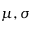<formula> <loc_0><loc_0><loc_500><loc_500>\mu , \sigma</formula> 